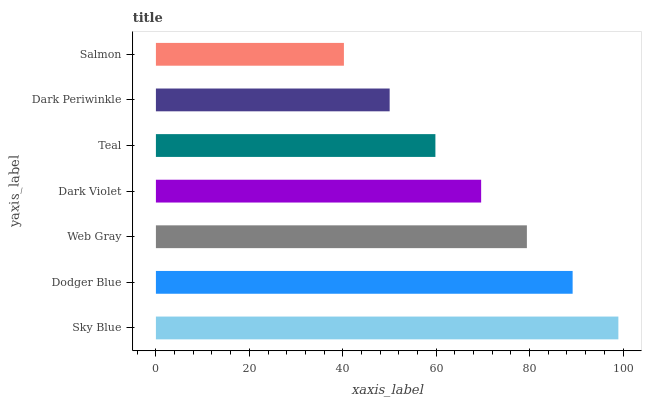Is Salmon the minimum?
Answer yes or no. Yes. Is Sky Blue the maximum?
Answer yes or no. Yes. Is Dodger Blue the minimum?
Answer yes or no. No. Is Dodger Blue the maximum?
Answer yes or no. No. Is Sky Blue greater than Dodger Blue?
Answer yes or no. Yes. Is Dodger Blue less than Sky Blue?
Answer yes or no. Yes. Is Dodger Blue greater than Sky Blue?
Answer yes or no. No. Is Sky Blue less than Dodger Blue?
Answer yes or no. No. Is Dark Violet the high median?
Answer yes or no. Yes. Is Dark Violet the low median?
Answer yes or no. Yes. Is Web Gray the high median?
Answer yes or no. No. Is Dark Periwinkle the low median?
Answer yes or no. No. 